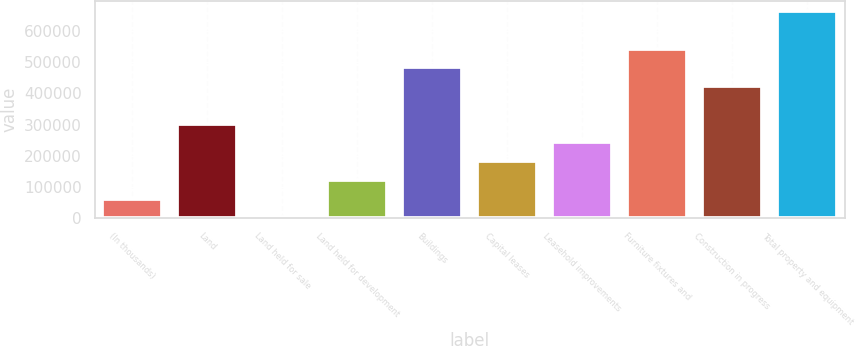Convert chart. <chart><loc_0><loc_0><loc_500><loc_500><bar_chart><fcel>(In thousands)<fcel>Land<fcel>Land held for sale<fcel>Land held for development<fcel>Buildings<fcel>Capital leases<fcel>Leasehold improvements<fcel>Furniture fixtures and<fcel>Construction in progress<fcel>Total property and equipment<nl><fcel>61718<fcel>302530<fcel>1515<fcel>121921<fcel>483139<fcel>182124<fcel>242327<fcel>543342<fcel>422936<fcel>663748<nl></chart> 